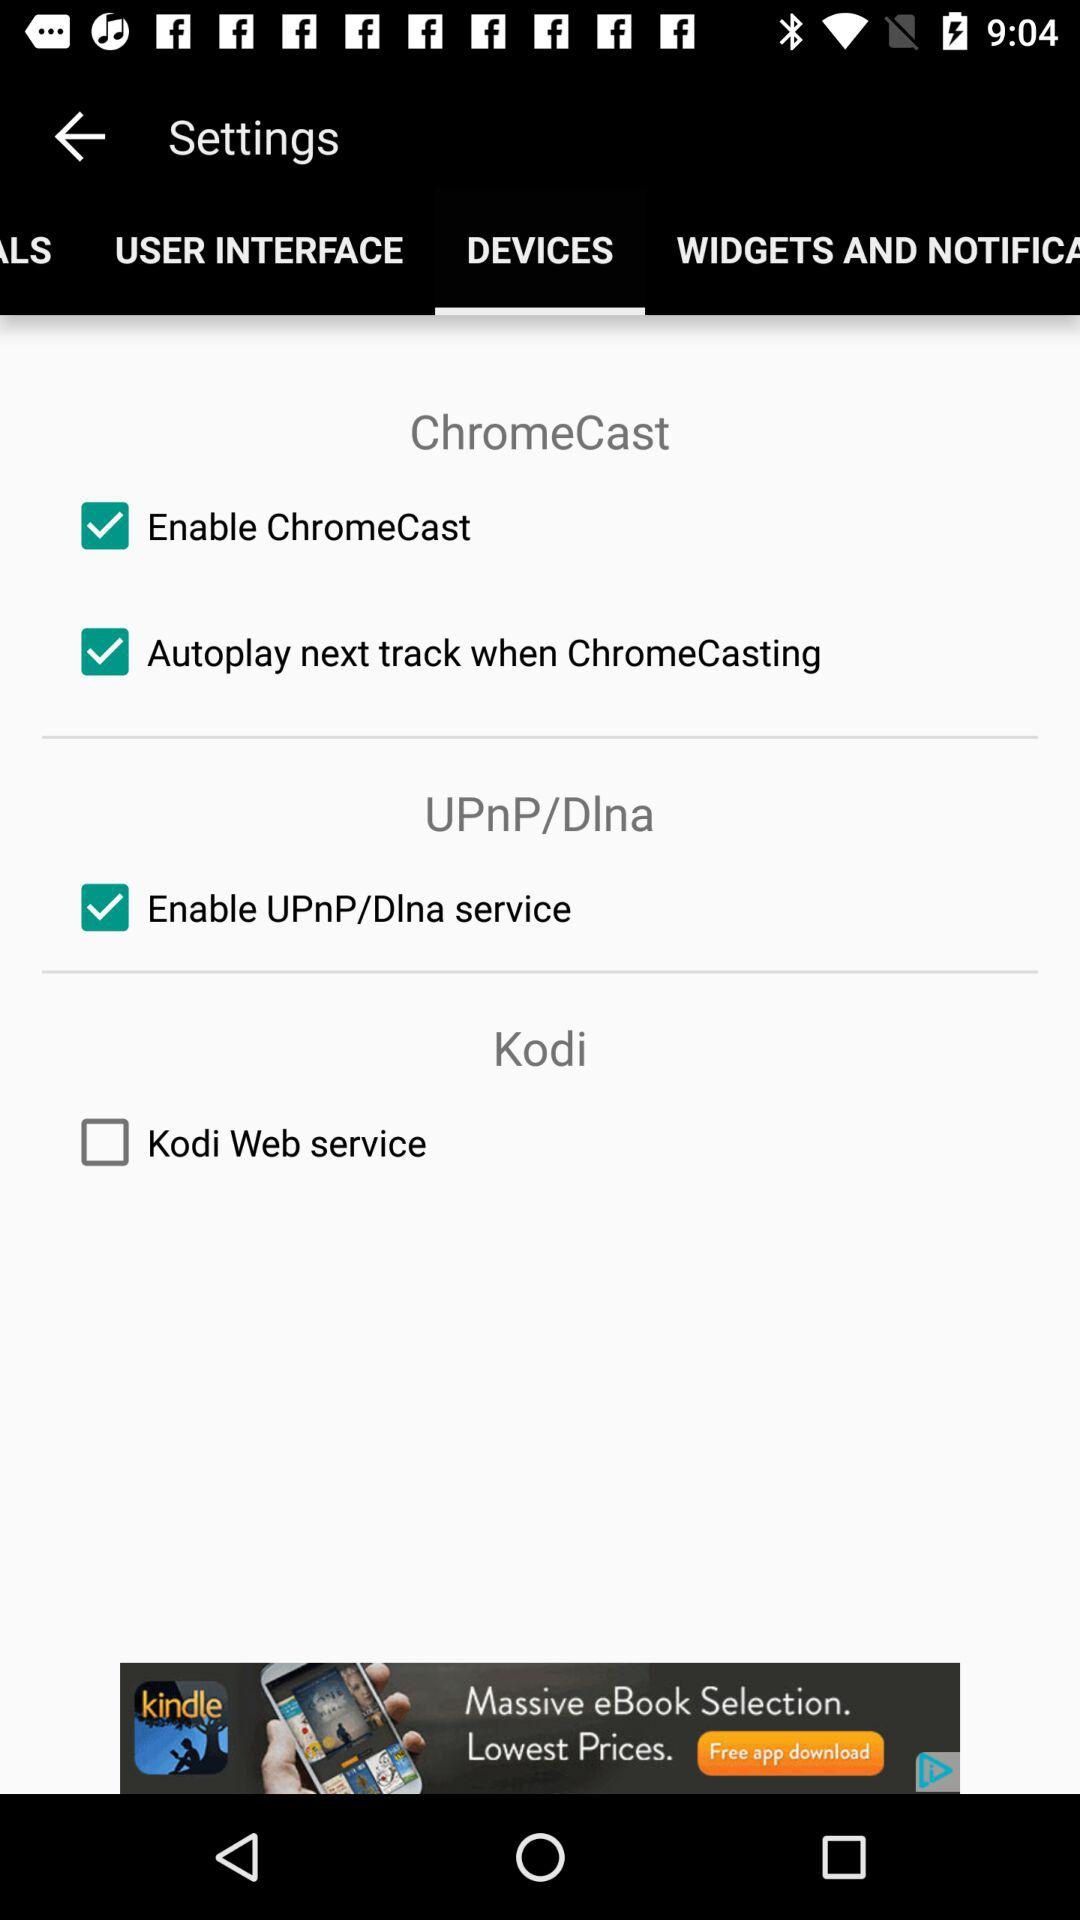Which tab is selected? The selected tab is "DEVICES". 